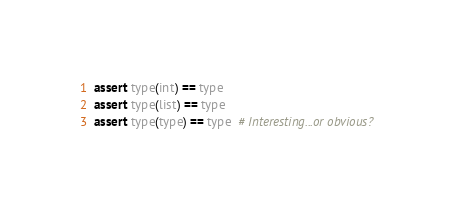Convert code to text. <code><loc_0><loc_0><loc_500><loc_500><_Python_>assert type(int) == type
assert type(list) == type
assert type(type) == type  # Interesting...or obvious?
</code> 